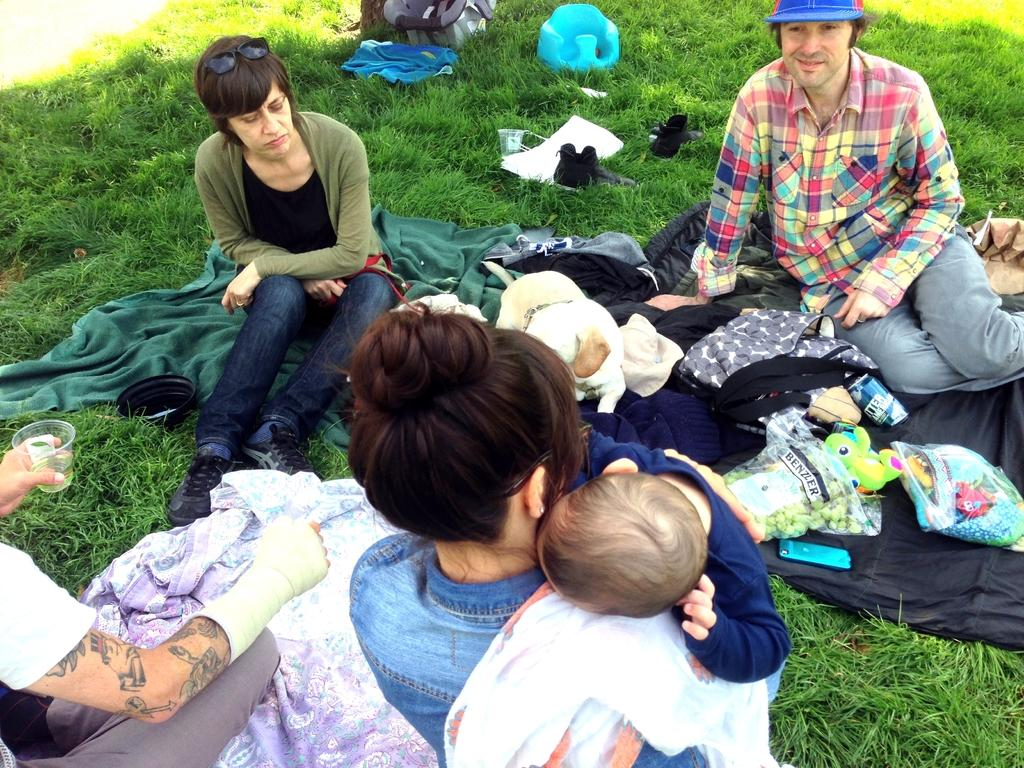What are the people in the image doing? The people in the image are sitting on mats. What can be seen near the people? There are objects near the people. What type of surface is visible at the bottom of the image? There is grass visible at the bottom of the image. Can you see any deer running through the waves in the image? There are no deer or waves present in the image. 